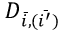<formula> <loc_0><loc_0><loc_500><loc_500>D _ { \bar { i } , ( \bar { i ^ { \prime } } ) }</formula> 